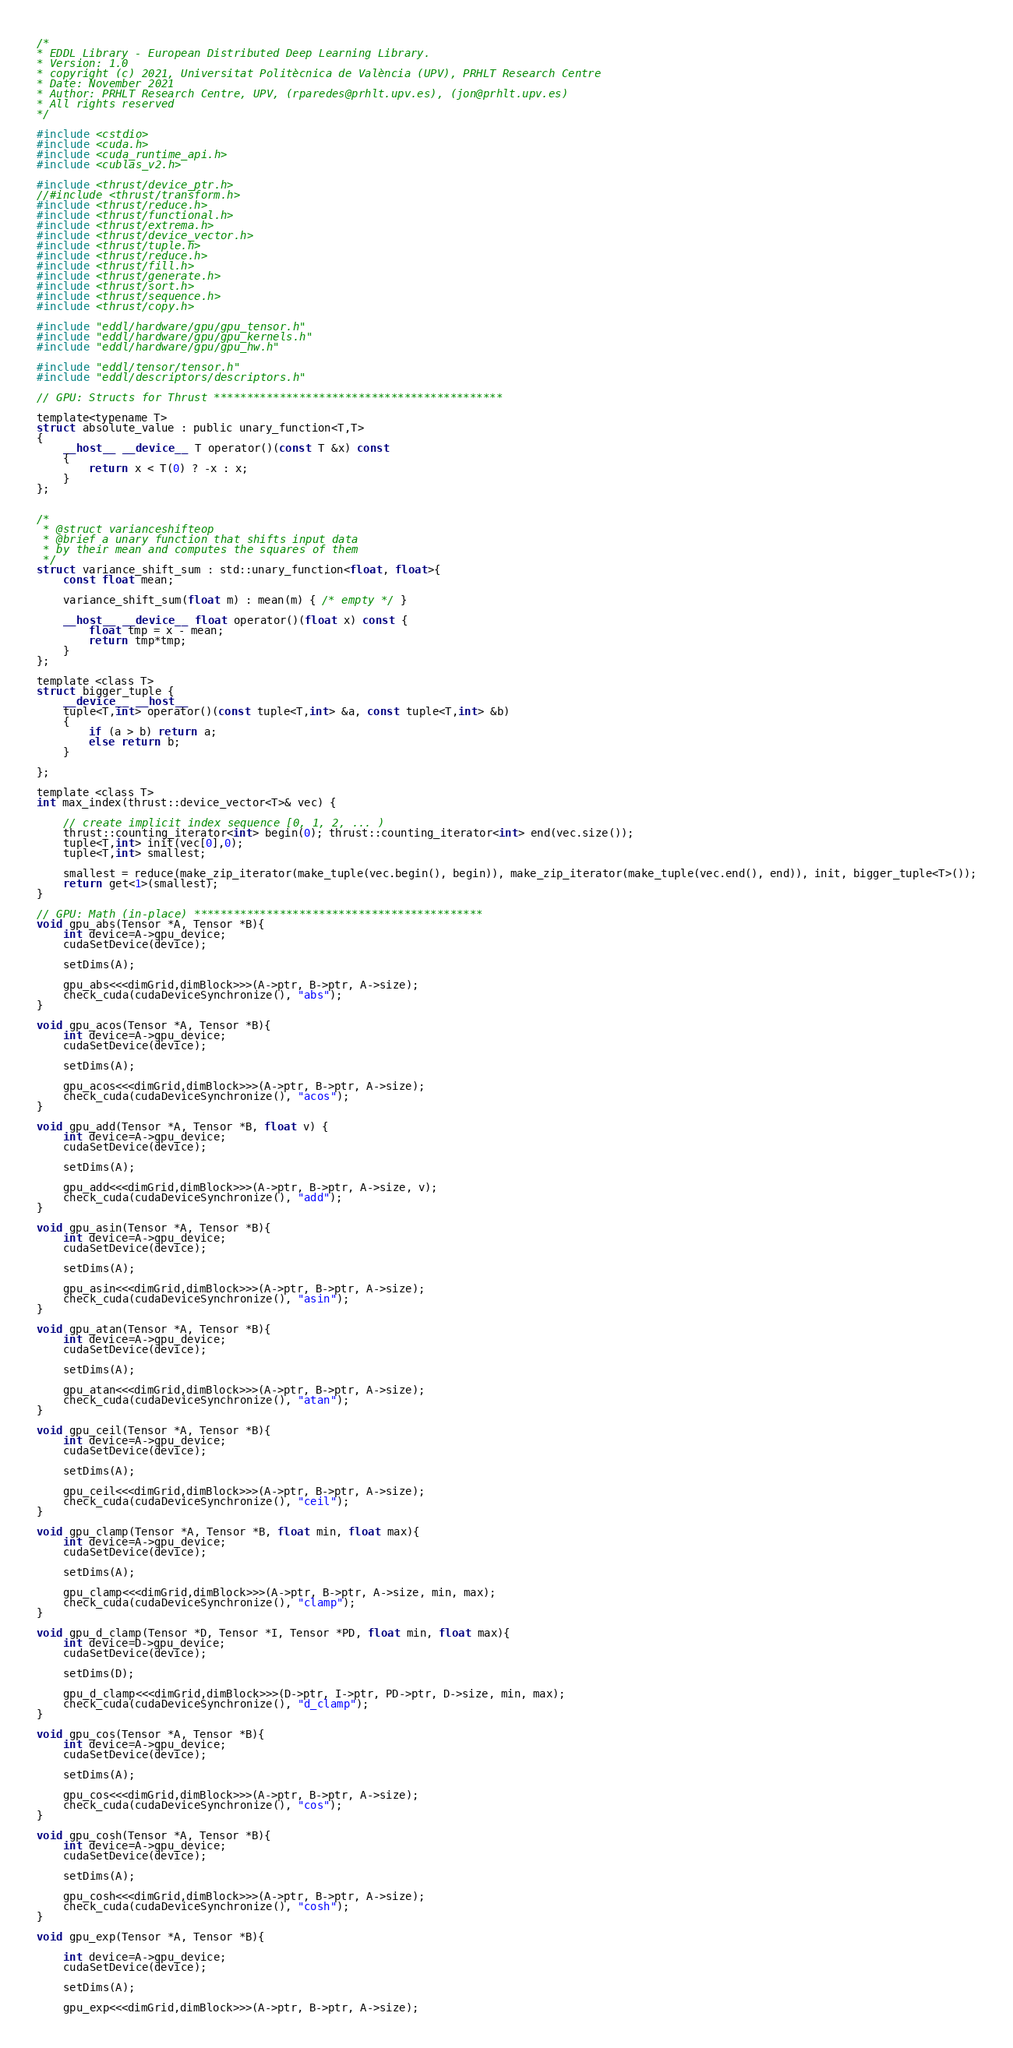<code> <loc_0><loc_0><loc_500><loc_500><_Cuda_>/*
* EDDL Library - European Distributed Deep Learning Library.
* Version: 1.0
* copyright (c) 2021, Universitat Politècnica de València (UPV), PRHLT Research Centre
* Date: November 2021
* Author: PRHLT Research Centre, UPV, (rparedes@prhlt.upv.es), (jon@prhlt.upv.es)
* All rights reserved
*/

#include <cstdio>
#include <cuda.h>
#include <cuda_runtime_api.h>
#include <cublas_v2.h>

#include <thrust/device_ptr.h>
//#include <thrust/transform.h>
#include <thrust/reduce.h>
#include <thrust/functional.h>
#include <thrust/extrema.h>
#include <thrust/device_vector.h>
#include <thrust/tuple.h>
#include <thrust/reduce.h>
#include <thrust/fill.h>
#include <thrust/generate.h>
#include <thrust/sort.h>
#include <thrust/sequence.h>
#include <thrust/copy.h>

#include "eddl/hardware/gpu/gpu_tensor.h"
#include "eddl/hardware/gpu/gpu_kernels.h"
#include "eddl/hardware/gpu/gpu_hw.h"

#include "eddl/tensor/tensor.h"
#include "eddl/descriptors/descriptors.h"

// GPU: Structs for Thrust ********************************************

template<typename T>
struct absolute_value : public unary_function<T,T>
{
    __host__ __device__ T operator()(const T &x) const
    {
        return x < T(0) ? -x : x;
    }
};


/*
 * @struct varianceshifteop
 * @brief a unary function that shifts input data
 * by their mean and computes the squares of them
 */
struct variance_shift_sum : std::unary_function<float, float>{
    const float mean;

    variance_shift_sum(float m) : mean(m) { /* empty */ }

    __host__ __device__ float operator()(float x) const {
        float tmp = x - mean;
        return tmp*tmp;
    }
};

template <class T>
struct bigger_tuple {
    __device__ __host__
    tuple<T,int> operator()(const tuple<T,int> &a, const tuple<T,int> &b)
    {
        if (a > b) return a;
        else return b;
    }

};

template <class T>
int max_index(thrust::device_vector<T>& vec) {

    // create implicit index sequence [0, 1, 2, ... )
    thrust::counting_iterator<int> begin(0); thrust::counting_iterator<int> end(vec.size());
    tuple<T,int> init(vec[0],0);
    tuple<T,int> smallest;

    smallest = reduce(make_zip_iterator(make_tuple(vec.begin(), begin)), make_zip_iterator(make_tuple(vec.end(), end)), init, bigger_tuple<T>());
    return get<1>(smallest);
}

// GPU: Math (in-place) ********************************************
void gpu_abs(Tensor *A, Tensor *B){
    int device=A->gpu_device;
    cudaSetDevice(device);

    setDims(A);

    gpu_abs<<<dimGrid,dimBlock>>>(A->ptr, B->ptr, A->size);
    check_cuda(cudaDeviceSynchronize(), "abs");
}

void gpu_acos(Tensor *A, Tensor *B){
    int device=A->gpu_device;
    cudaSetDevice(device);

    setDims(A);

    gpu_acos<<<dimGrid,dimBlock>>>(A->ptr, B->ptr, A->size);
    check_cuda(cudaDeviceSynchronize(), "acos");
}

void gpu_add(Tensor *A, Tensor *B, float v) {
    int device=A->gpu_device;
    cudaSetDevice(device);

    setDims(A);

    gpu_add<<<dimGrid,dimBlock>>>(A->ptr, B->ptr, A->size, v);
    check_cuda(cudaDeviceSynchronize(), "add");
}

void gpu_asin(Tensor *A, Tensor *B){
    int device=A->gpu_device;
    cudaSetDevice(device);

    setDims(A);

    gpu_asin<<<dimGrid,dimBlock>>>(A->ptr, B->ptr, A->size);
    check_cuda(cudaDeviceSynchronize(), "asin");
}

void gpu_atan(Tensor *A, Tensor *B){
    int device=A->gpu_device;
    cudaSetDevice(device);

    setDims(A);

    gpu_atan<<<dimGrid,dimBlock>>>(A->ptr, B->ptr, A->size);
    check_cuda(cudaDeviceSynchronize(), "atan");
}

void gpu_ceil(Tensor *A, Tensor *B){
    int device=A->gpu_device;
    cudaSetDevice(device);

    setDims(A);

    gpu_ceil<<<dimGrid,dimBlock>>>(A->ptr, B->ptr, A->size);
    check_cuda(cudaDeviceSynchronize(), "ceil");
}

void gpu_clamp(Tensor *A, Tensor *B, float min, float max){
    int device=A->gpu_device;
    cudaSetDevice(device);

    setDims(A);

    gpu_clamp<<<dimGrid,dimBlock>>>(A->ptr, B->ptr, A->size, min, max);
    check_cuda(cudaDeviceSynchronize(), "clamp");
}

void gpu_d_clamp(Tensor *D, Tensor *I, Tensor *PD, float min, float max){
    int device=D->gpu_device;
    cudaSetDevice(device);

    setDims(D);

    gpu_d_clamp<<<dimGrid,dimBlock>>>(D->ptr, I->ptr, PD->ptr, D->size, min, max);
    check_cuda(cudaDeviceSynchronize(), "d_clamp");
}

void gpu_cos(Tensor *A, Tensor *B){
    int device=A->gpu_device;
    cudaSetDevice(device);

    setDims(A);

    gpu_cos<<<dimGrid,dimBlock>>>(A->ptr, B->ptr, A->size);
    check_cuda(cudaDeviceSynchronize(), "cos");
}

void gpu_cosh(Tensor *A, Tensor *B){
    int device=A->gpu_device;
    cudaSetDevice(device);

    setDims(A);

    gpu_cosh<<<dimGrid,dimBlock>>>(A->ptr, B->ptr, A->size);
    check_cuda(cudaDeviceSynchronize(), "cosh");
}

void gpu_exp(Tensor *A, Tensor *B){

    int device=A->gpu_device;
    cudaSetDevice(device);

    setDims(A);

    gpu_exp<<<dimGrid,dimBlock>>>(A->ptr, B->ptr, A->size);</code> 